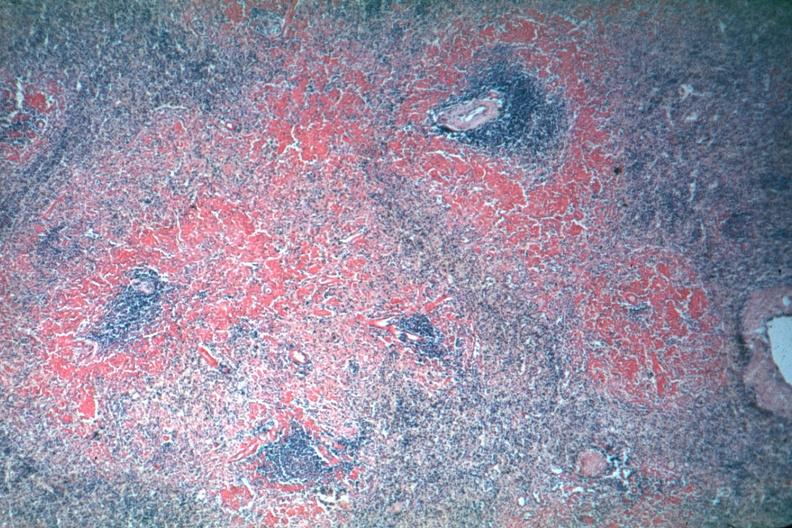does this image show not sure of stain may be sirus red perifollicular amyloid deposits are well shown though exposure is not the best?
Answer the question using a single word or phrase. Yes 